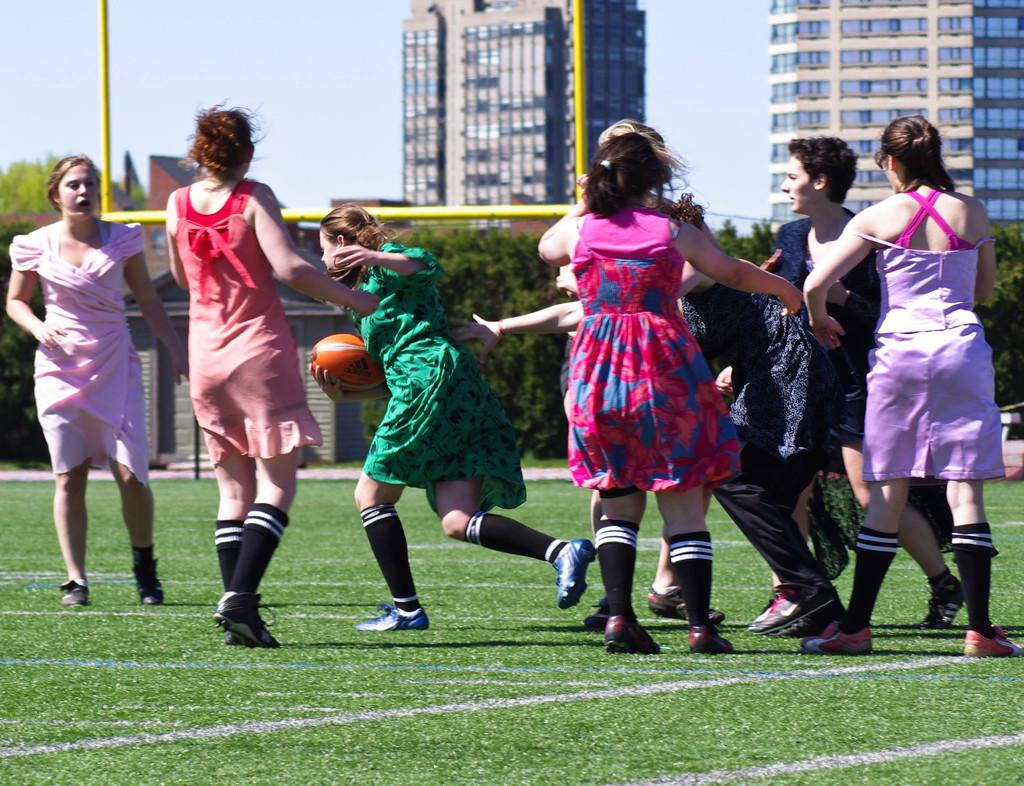How many people are in the image? There are persons standing in the image. What is the woman holding in the image? A woman is holding a ball in the image. What can be seen in the background of the image? Buildings, the sky, trees, and grass are visible in the background. What is the price of the ball the woman is holding in the image? There is no information about the price of the ball in the image. How many men are present in the image? The provided facts do not mention the gender of the persons standing in the image, so we cannot determine the number of men. 